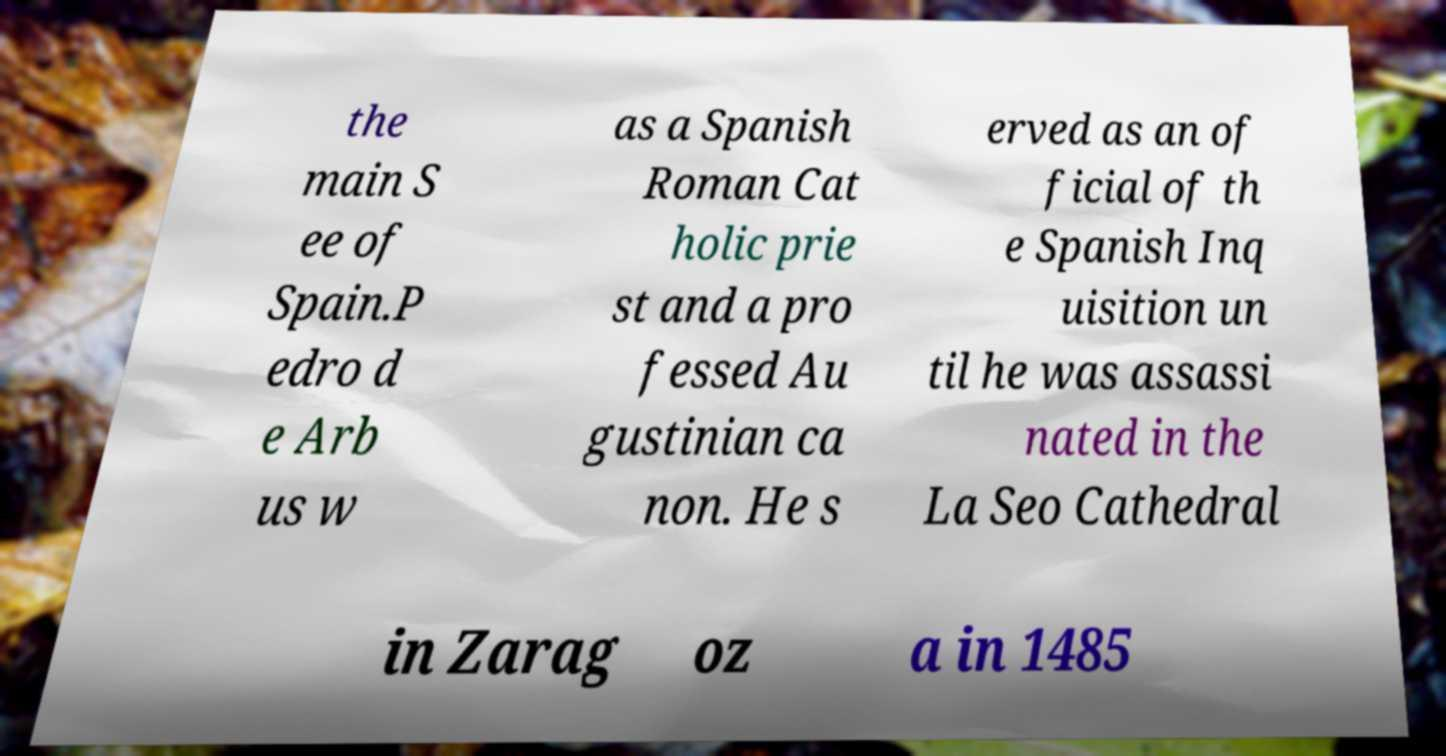Please identify and transcribe the text found in this image. the main S ee of Spain.P edro d e Arb us w as a Spanish Roman Cat holic prie st and a pro fessed Au gustinian ca non. He s erved as an of ficial of th e Spanish Inq uisition un til he was assassi nated in the La Seo Cathedral in Zarag oz a in 1485 